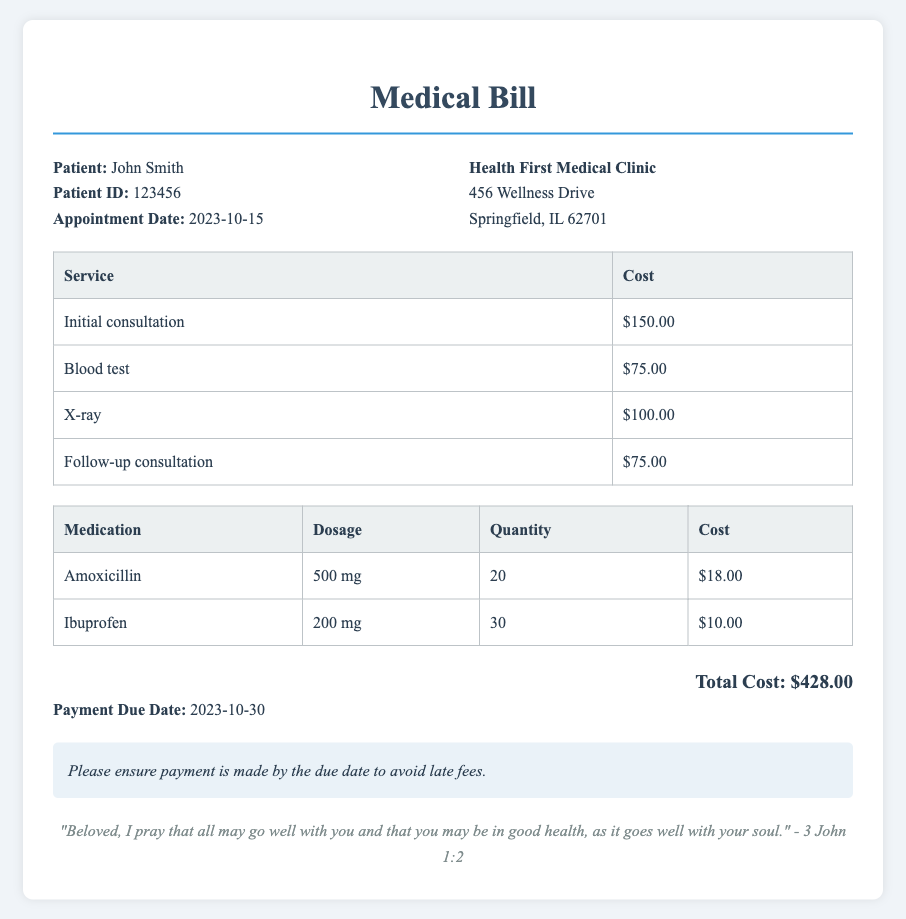What is the patient's name? The patient's name is provided at the top of the document under the patient info section.
Answer: John Smith What was the date of the appointment? The document lists the appointment date right under the patient's name.
Answer: 2023-10-15 How much was charged for the blood test? The cost for the blood test can be found in the itemized services table in the document.
Answer: $75.00 What is the total cost of the medical bill? The total cost is summarized at the bottom of the document, combining all services and medications.
Answer: $428.00 What is the payment due date? The payment due date is specified at the end of the document.
Answer: 2023-10-30 How many units of Amoxicillin were prescribed? The quantity prescribed for Amoxicillin can be found in the medications table in the document.
Answer: 20 What scripture is referenced at the bottom of the bill? The scripture reference is included at the very end of the document.
Answer: 3 John 1:2 Which service has the highest cost? The service with the highest cost can be identified by looking at the itemized table of services.
Answer: Initial consultation What medications are listed in the bill? The medications are listed in their own table within the document.
Answer: Amoxicillin, Ibuprofen 